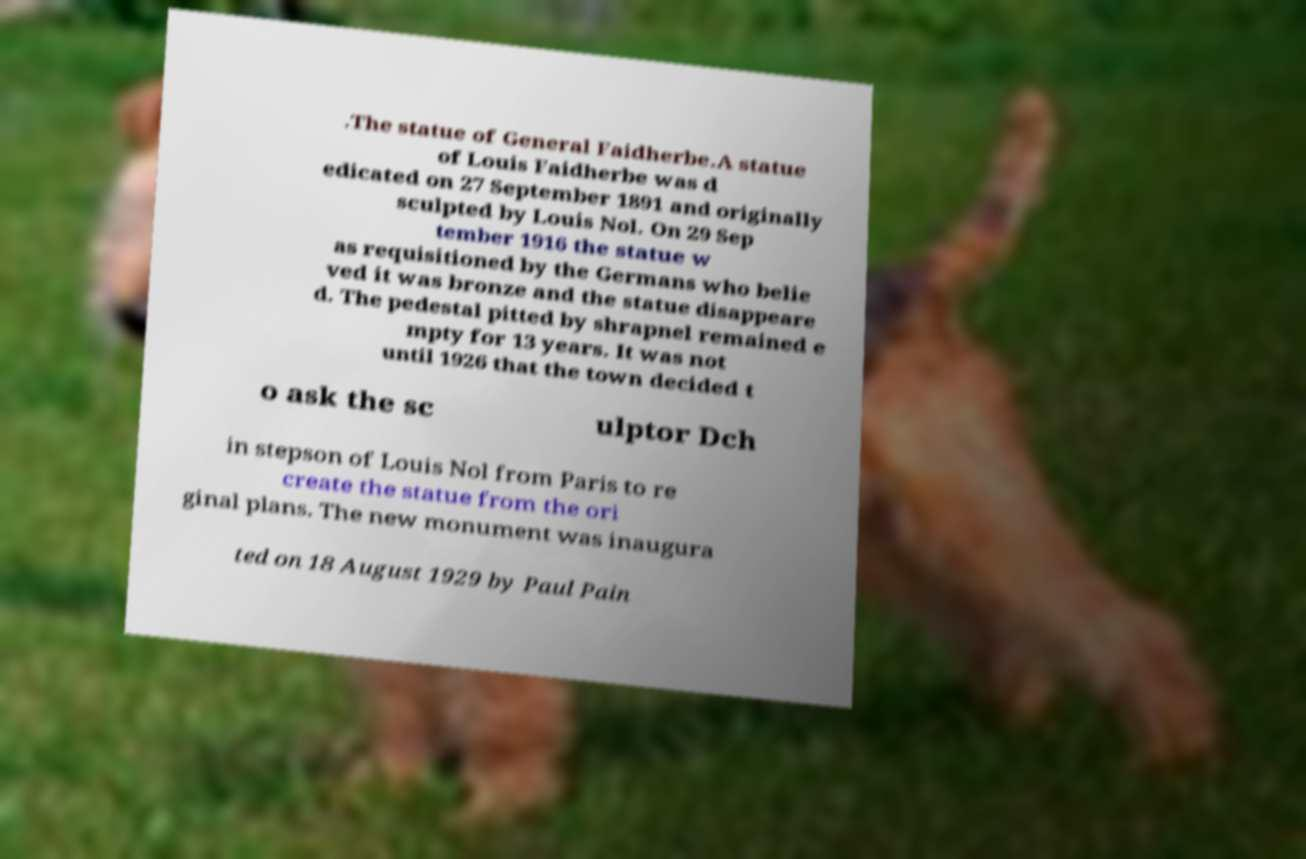Please identify and transcribe the text found in this image. .The statue of General Faidherbe.A statue of Louis Faidherbe was d edicated on 27 September 1891 and originally sculpted by Louis Nol. On 29 Sep tember 1916 the statue w as requisitioned by the Germans who belie ved it was bronze and the statue disappeare d. The pedestal pitted by shrapnel remained e mpty for 13 years. It was not until 1926 that the town decided t o ask the sc ulptor Dch in stepson of Louis Nol from Paris to re create the statue from the ori ginal plans. The new monument was inaugura ted on 18 August 1929 by Paul Pain 